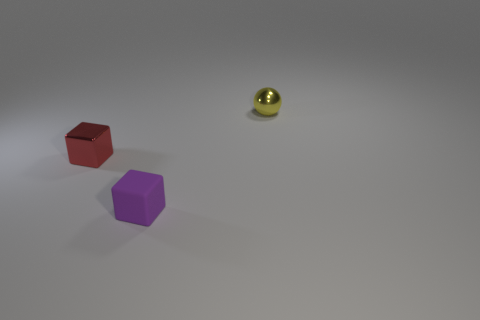Add 2 large purple shiny balls. How many objects exist? 5 Subtract all spheres. How many objects are left? 2 Subtract 0 yellow blocks. How many objects are left? 3 Subtract all metal objects. Subtract all big yellow cylinders. How many objects are left? 1 Add 1 purple matte blocks. How many purple matte blocks are left? 2 Add 1 metallic objects. How many metallic objects exist? 3 